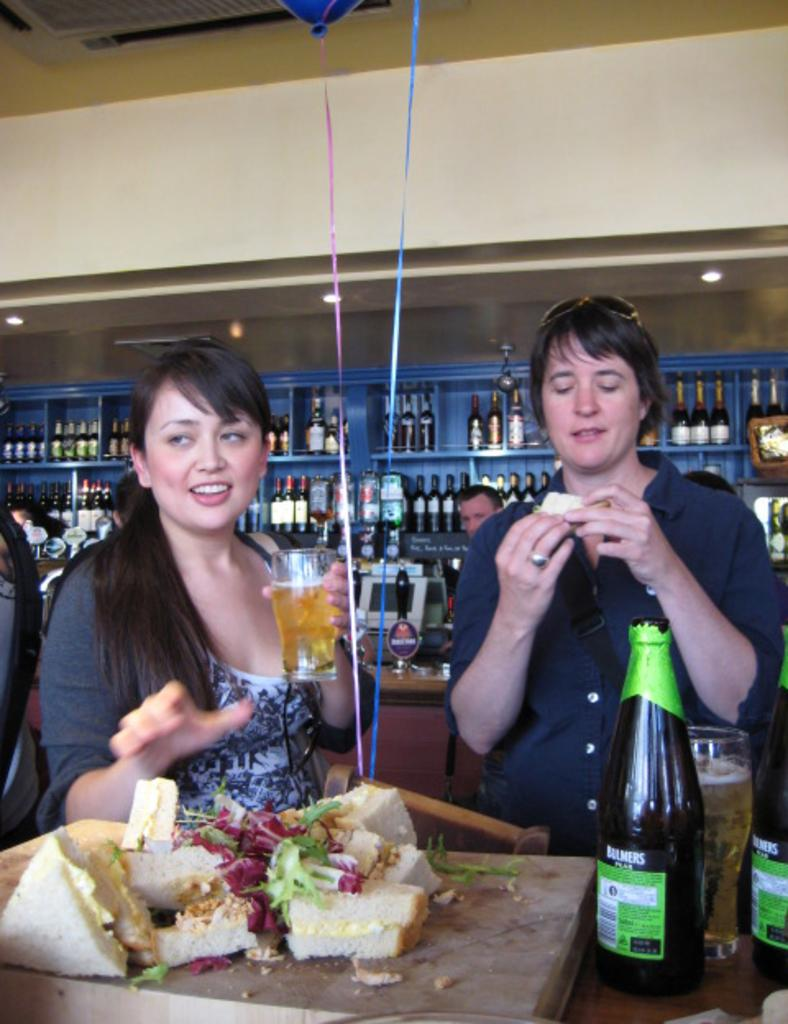<image>
Offer a succinct explanation of the picture presented. Two people eating and drinking behind a bottle that says Bulmers on it. 